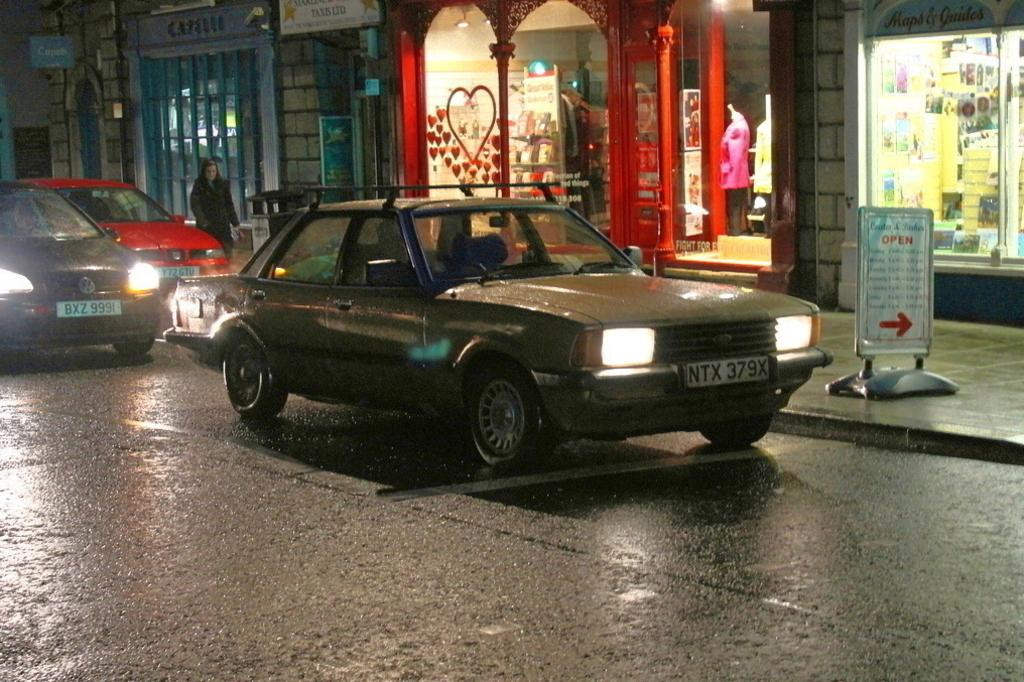What is the main feature of the image? There is a road in the image. What is happening on the road? There are vehicles on the road. Can you describe the person near the road? There is a person visible near the road. What is attached to the building in the image? There are boards attached to a building in the image. Where is the birth taking place in the image? There is no indication of a birth taking place in the image. What type of agreement is being signed on the boards attached to the building? There is no agreement being signed or mentioned in the image. 